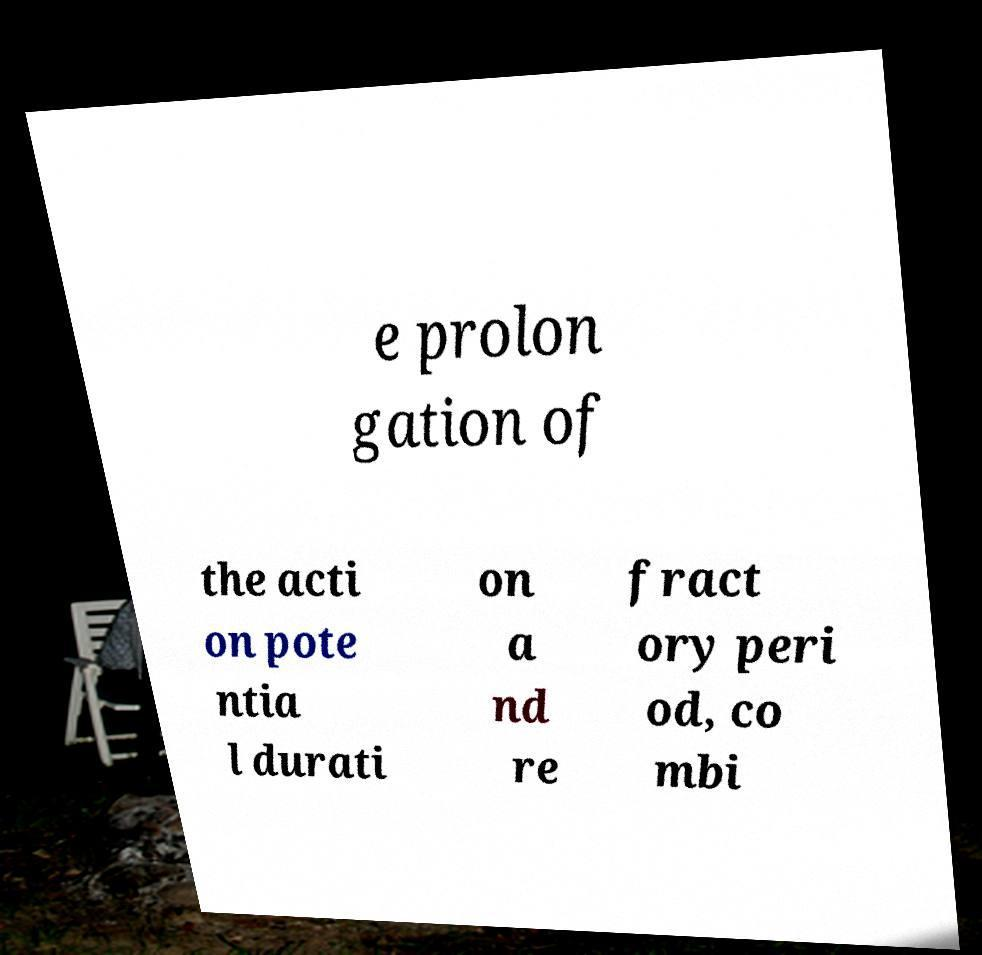Could you extract and type out the text from this image? e prolon gation of the acti on pote ntia l durati on a nd re fract ory peri od, co mbi 